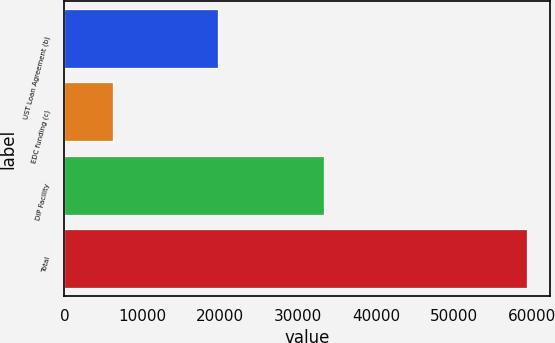Convert chart to OTSL. <chart><loc_0><loc_0><loc_500><loc_500><bar_chart><fcel>UST Loan Agreement (b)<fcel>EDC funding (c)<fcel>DIP Facility<fcel>Total<nl><fcel>19761<fcel>6294<fcel>33300<fcel>59355<nl></chart> 